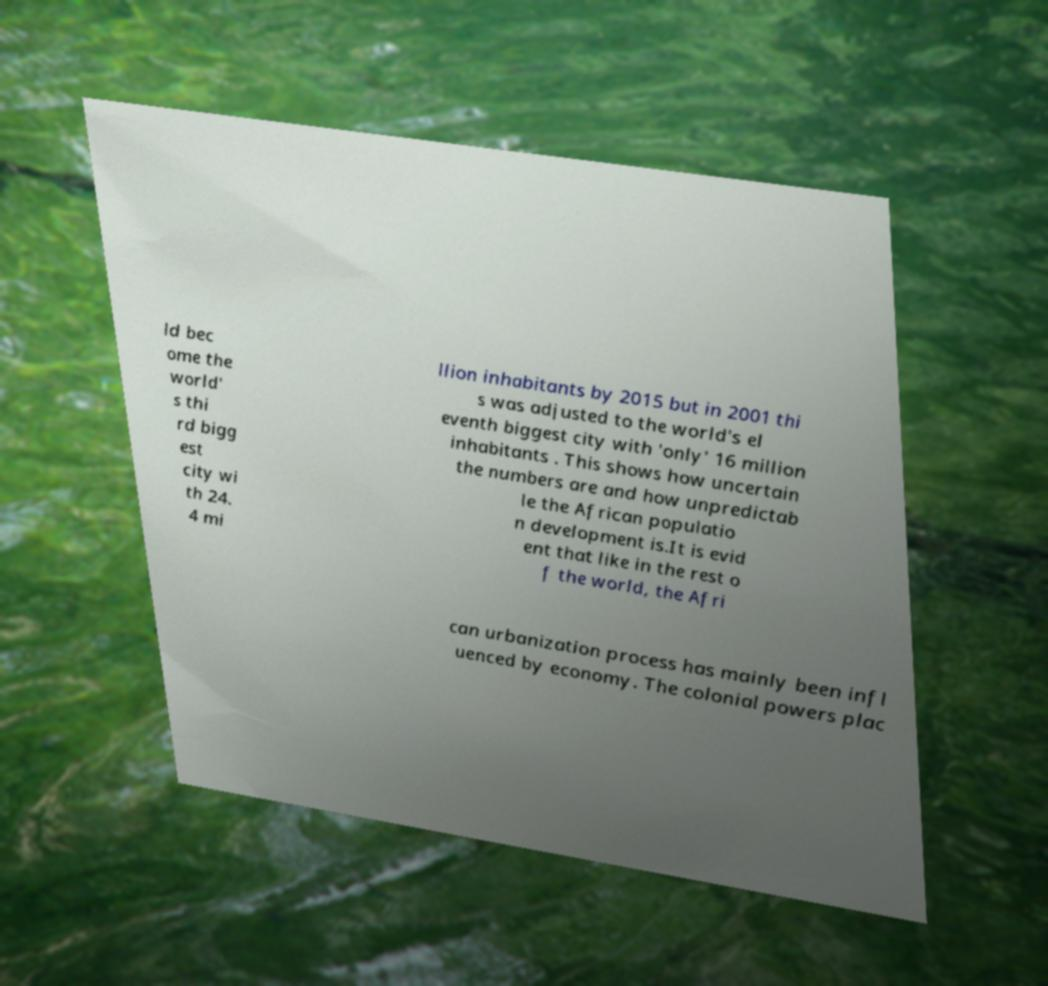What messages or text are displayed in this image? I need them in a readable, typed format. ld bec ome the world' s thi rd bigg est city wi th 24. 4 mi llion inhabitants by 2015 but in 2001 thi s was adjusted to the world's el eventh biggest city with 'only' 16 million inhabitants . This shows how uncertain the numbers are and how unpredictab le the African populatio n development is.It is evid ent that like in the rest o f the world, the Afri can urbanization process has mainly been infl uenced by economy. The colonial powers plac 